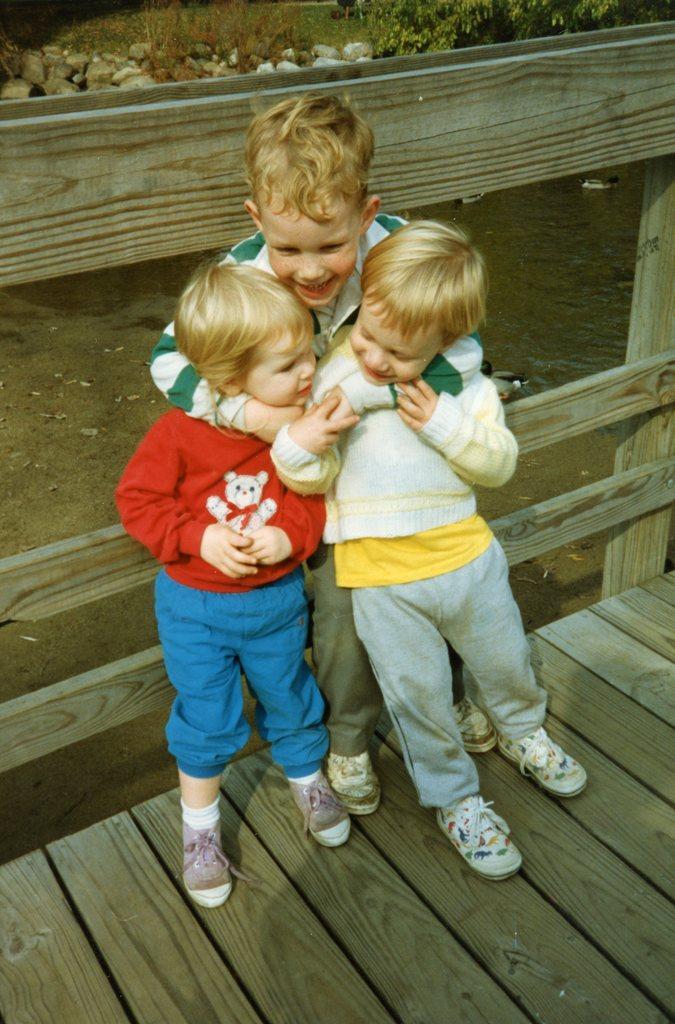In one or two sentences, can you explain what this image depicts? In this image there are three kids standing on a wooden surface, behind them there is a wooden railing, in the background there is water surface, stones and plants. 